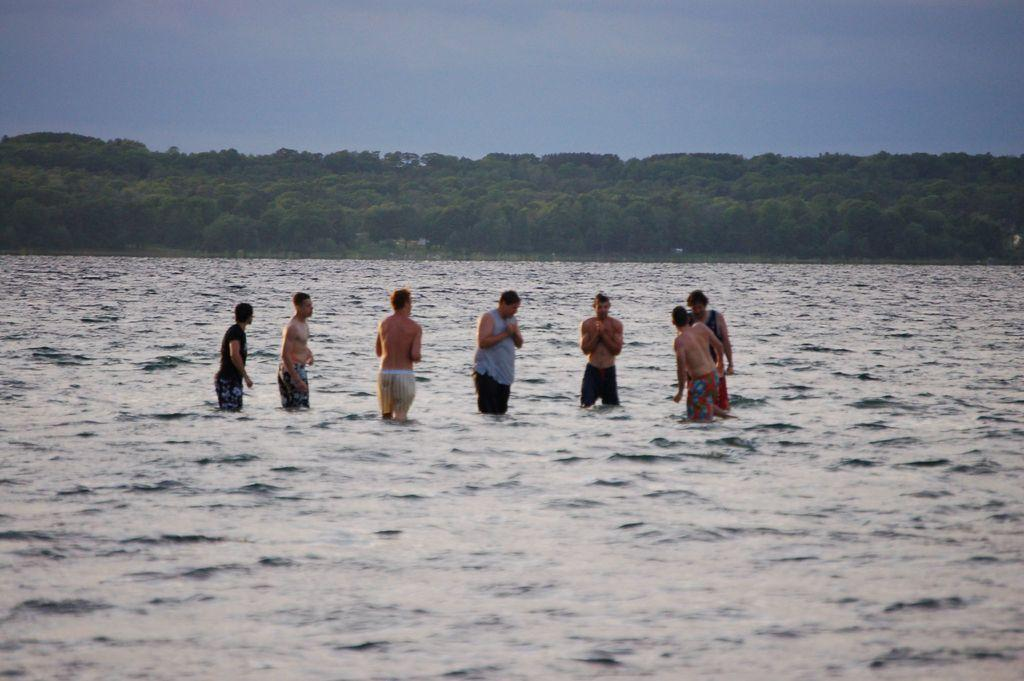What are the people in the image doing? The people in the image are standing in the water. What can be seen in the background of the image? There are trees and the sky visible in the background of the image. What type of agreement can be seen between the people and the airplane in the image? There is no airplane present in the image, so there cannot be any agreement between the people and an airplane. 